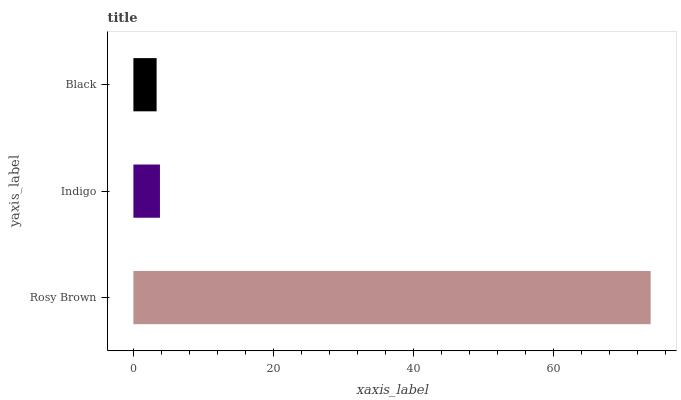Is Black the minimum?
Answer yes or no. Yes. Is Rosy Brown the maximum?
Answer yes or no. Yes. Is Indigo the minimum?
Answer yes or no. No. Is Indigo the maximum?
Answer yes or no. No. Is Rosy Brown greater than Indigo?
Answer yes or no. Yes. Is Indigo less than Rosy Brown?
Answer yes or no. Yes. Is Indigo greater than Rosy Brown?
Answer yes or no. No. Is Rosy Brown less than Indigo?
Answer yes or no. No. Is Indigo the high median?
Answer yes or no. Yes. Is Indigo the low median?
Answer yes or no. Yes. Is Black the high median?
Answer yes or no. No. Is Rosy Brown the low median?
Answer yes or no. No. 